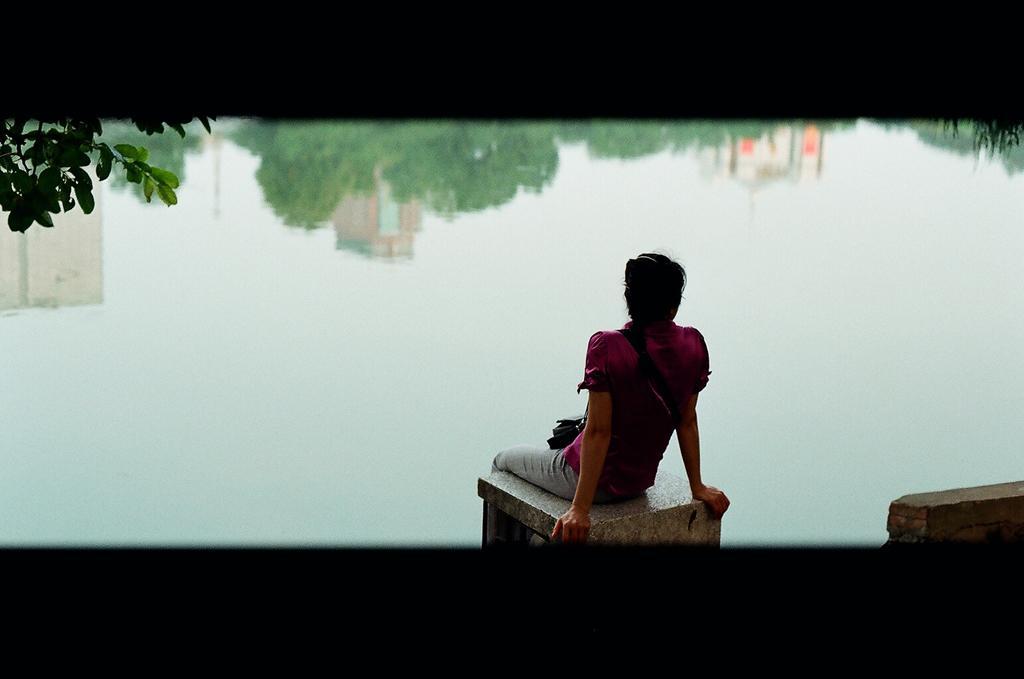Could you give a brief overview of what you see in this image? In the image we can see a person sitting and wearing clothes. Here we can see water and leaves. On the water we can see the reflection of the sky, trees and buildings. 